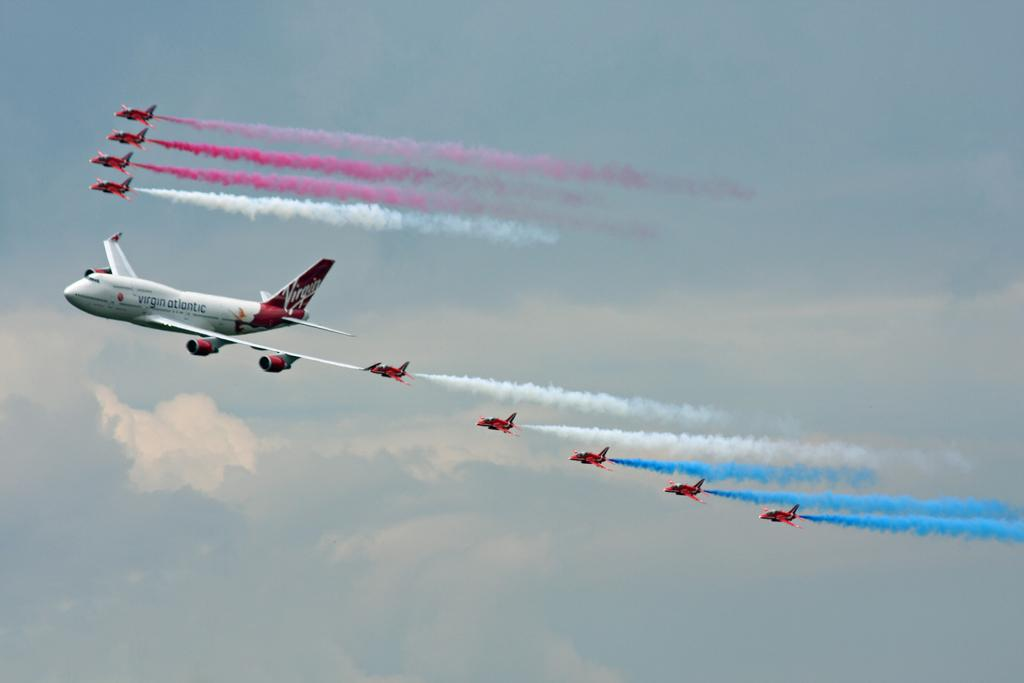What is the main subject of the image? The main subject of the image is aeroplanes. What are the aeroplanes doing in the image? The aeroplanes are flying in the sky. What additional detail can be observed about the aeroplanes in the image? The aeroplanes are releasing colorful smoke in the air. What type of skate is being used by the aeroplanes in the image? There is no skate present in the image; the aeroplanes are flying in the sky and releasing colorful smoke. 